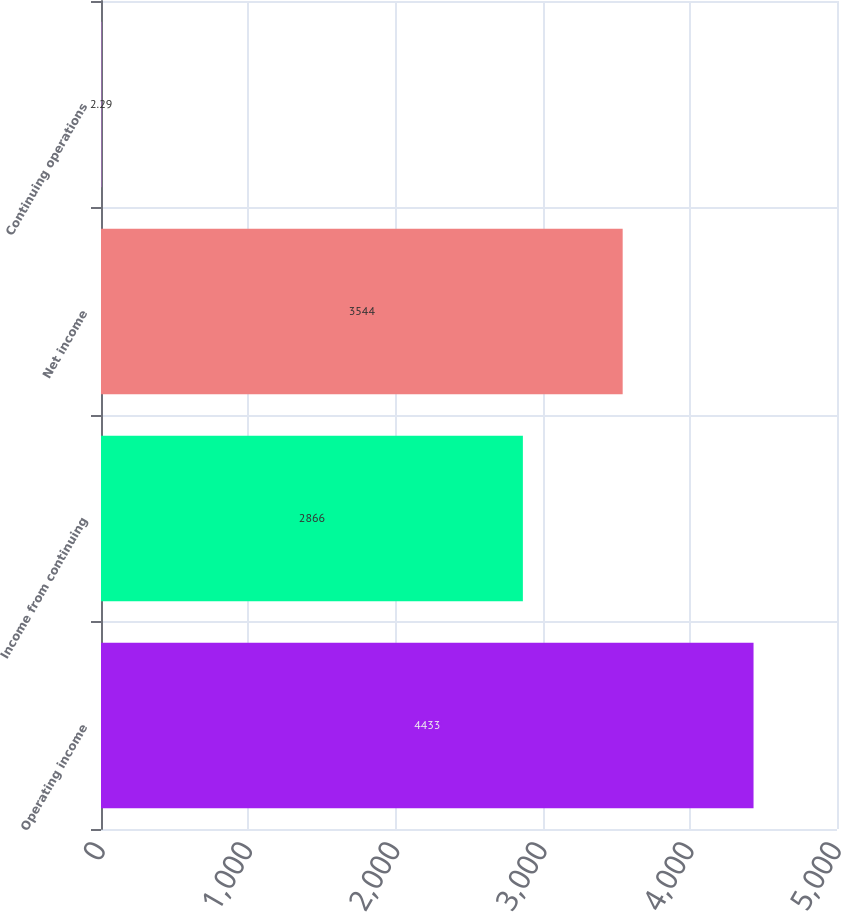Convert chart. <chart><loc_0><loc_0><loc_500><loc_500><bar_chart><fcel>Operating income<fcel>Income from continuing<fcel>Net income<fcel>Continuing operations<nl><fcel>4433<fcel>2866<fcel>3544<fcel>2.29<nl></chart> 